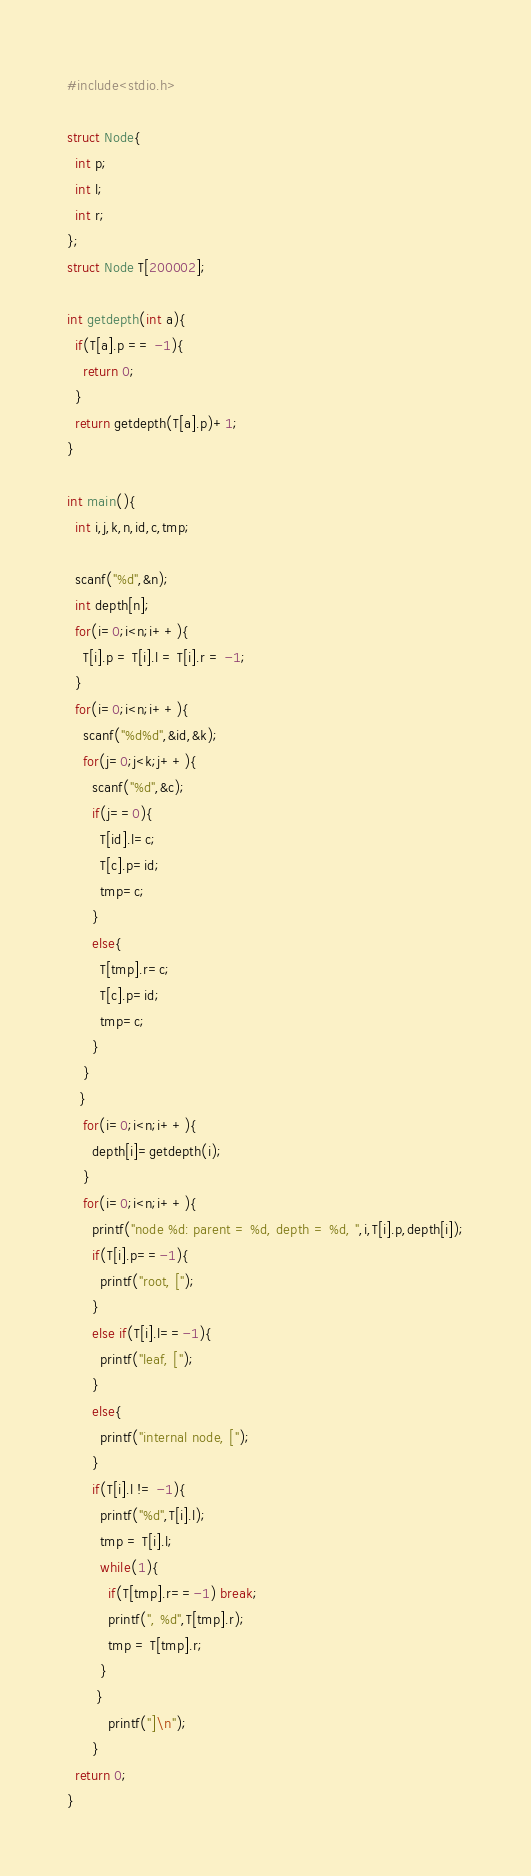Convert code to text. <code><loc_0><loc_0><loc_500><loc_500><_C_>#include<stdio.h>

struct Node{
  int p;
  int l;
  int r;
};
struct Node T[200002];

int getdepth(int a){
  if(T[a].p == -1){
    return 0;
  }
  return getdepth(T[a].p)+1;
}

int main(){
  int i,j,k,n,id,c,tmp;

  scanf("%d",&n);
  int depth[n];
  for(i=0;i<n;i++){
    T[i].p = T[i].l = T[i].r = -1;
  }
  for(i=0;i<n;i++){
    scanf("%d%d",&id,&k);
    for(j=0;j<k;j++){
      scanf("%d",&c);
      if(j==0){
        T[id].l=c;
        T[c].p=id;
        tmp=c;
      }
      else{
        T[tmp].r=c;
        T[c].p=id;
        tmp=c;
      }
    }
   }
    for(i=0;i<n;i++){
      depth[i]=getdepth(i);
    }
    for(i=0;i<n;i++){
      printf("node %d: parent = %d, depth = %d, ",i,T[i].p,depth[i]);
      if(T[i].p==-1){
        printf("root, [");
      }
      else if(T[i].l==-1){
        printf("leaf, [");
      }
      else{
        printf("internal node, [");
      }
      if(T[i].l != -1){
        printf("%d",T[i].l);
        tmp = T[i].l;
        while(1){
          if(T[tmp].r==-1) break;
          printf(", %d",T[tmp].r);
          tmp = T[tmp].r;
        }
       }
          printf("]\n");
      }
  return 0;
}

</code> 